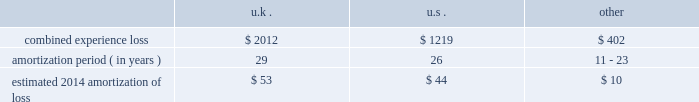Period .
The discount reflects our incremental borrowing rate , which matches the lifetime of the liability .
Significant changes in the discount rate selected or the estimations of sublease income in the case of leases could impact the amounts recorded .
Other associated costs with restructuring activities we recognize other costs associated with restructuring activities as they are incurred , including moving costs and consulting and legal fees .
Pensions we sponsor defined benefit pension plans throughout the world .
Our most significant plans are located in the u.s. , the u.k. , the netherlands and canada .
Our significant u.s. , u.k .
And canadian pension plans are closed to new entrants .
We have ceased crediting future benefits relating to salary and service for our u.s. , u.k .
And canadian plans .
Recognition of gains and losses and prior service certain changes in the value of the obligation and in the value of plan assets , which may occur due to various factors such as changes in the discount rate and actuarial assumptions , actual demographic experience and/or plan asset performance are not immediately recognized in net income .
Such changes are recognized in other comprehensive income and are amortized into net income as part of the net periodic benefit cost .
Unrecognized gains and losses that have been deferred in other comprehensive income , as previously described , are amortized into compensation and benefits expense as a component of periodic pension expense based on the average expected future service of active employees for our plans in the netherlands and canada , or the average life expectancy of the u.s .
And u.k .
Plan members .
After the effective date of the plan amendments to cease crediting future benefits relating to service , unrecognized gains and losses are also be based on the average life expectancy of members in the canadian plans .
We amortize any prior service expense or credits that arise as a result of plan changes over a period consistent with the amortization of gains and losses .
As of december 31 , 2013 , our pension plans have deferred losses that have not yet been recognized through income in the consolidated financial statements .
We amortize unrecognized actuarial losses outside of a corridor , which is defined as 10% ( 10 % ) of the greater of market-related value of plan assets or projected benefit obligation .
To the extent not offset by future gains , incremental amortization as calculated above will continue to affect future pension expense similarly until fully amortized .
The table discloses our combined experience loss , the number of years over which we are amortizing the experience loss , and the estimated 2014 amortization of loss by country ( amounts in millions ) : .
The unrecognized prior service cost at december 31 , 2013 was $ 27 million in the u.k .
And other plans .
For the u.s .
Pension plans we use a market-related valuation of assets approach to determine the expected return on assets , which is a component of net periodic benefit cost recognized in the consolidated statements of income .
This approach recognizes 20% ( 20 % ) of any gains or losses in the current year's value of market-related assets , with the remaining 80% ( 80 % ) spread over the next four years .
As this approach recognizes gains or losses over a five-year period , the future value of assets and therefore , our net periodic benefit cost will be impacted as previously deferred gains or losses are recorded .
As of december 31 , 2013 , the market-related value of assets was $ 1.8 billion .
We do not use the market-related valuation approach to determine the funded status of the u.s .
Plans recorded in the consolidated statements of financial position .
Instead , we record and present the funded status in the consolidated statements of financial position based on the fair value of the plan assets .
As of december 31 , 2013 , the fair value of plan assets was $ 1.9 billion .
Our non-u.s .
Plans use fair value to determine expected return on assets. .
What is the total estimated amortization of loss in 2014 for aon , ( in millions ) ? 
Computations: ((53 + 44) + 10)
Answer: 107.0. Period .
The discount reflects our incremental borrowing rate , which matches the lifetime of the liability .
Significant changes in the discount rate selected or the estimations of sublease income in the case of leases could impact the amounts recorded .
Other associated costs with restructuring activities we recognize other costs associated with restructuring activities as they are incurred , including moving costs and consulting and legal fees .
Pensions we sponsor defined benefit pension plans throughout the world .
Our most significant plans are located in the u.s. , the u.k. , the netherlands and canada .
Our significant u.s. , u.k .
And canadian pension plans are closed to new entrants .
We have ceased crediting future benefits relating to salary and service for our u.s. , u.k .
And canadian plans .
Recognition of gains and losses and prior service certain changes in the value of the obligation and in the value of plan assets , which may occur due to various factors such as changes in the discount rate and actuarial assumptions , actual demographic experience and/or plan asset performance are not immediately recognized in net income .
Such changes are recognized in other comprehensive income and are amortized into net income as part of the net periodic benefit cost .
Unrecognized gains and losses that have been deferred in other comprehensive income , as previously described , are amortized into compensation and benefits expense as a component of periodic pension expense based on the average expected future service of active employees for our plans in the netherlands and canada , or the average life expectancy of the u.s .
And u.k .
Plan members .
After the effective date of the plan amendments to cease crediting future benefits relating to service , unrecognized gains and losses are also be based on the average life expectancy of members in the canadian plans .
We amortize any prior service expense or credits that arise as a result of plan changes over a period consistent with the amortization of gains and losses .
As of december 31 , 2013 , our pension plans have deferred losses that have not yet been recognized through income in the consolidated financial statements .
We amortize unrecognized actuarial losses outside of a corridor , which is defined as 10% ( 10 % ) of the greater of market-related value of plan assets or projected benefit obligation .
To the extent not offset by future gains , incremental amortization as calculated above will continue to affect future pension expense similarly until fully amortized .
The table discloses our combined experience loss , the number of years over which we are amortizing the experience loss , and the estimated 2014 amortization of loss by country ( amounts in millions ) : .
The unrecognized prior service cost at december 31 , 2013 was $ 27 million in the u.k .
And other plans .
For the u.s .
Pension plans we use a market-related valuation of assets approach to determine the expected return on assets , which is a component of net periodic benefit cost recognized in the consolidated statements of income .
This approach recognizes 20% ( 20 % ) of any gains or losses in the current year's value of market-related assets , with the remaining 80% ( 80 % ) spread over the next four years .
As this approach recognizes gains or losses over a five-year period , the future value of assets and therefore , our net periodic benefit cost will be impacted as previously deferred gains or losses are recorded .
As of december 31 , 2013 , the market-related value of assets was $ 1.8 billion .
We do not use the market-related valuation approach to determine the funded status of the u.s .
Plans recorded in the consolidated statements of financial position .
Instead , we record and present the funded status in the consolidated statements of financial position based on the fair value of the plan assets .
As of december 31 , 2013 , the fair value of plan assets was $ 1.9 billion .
Our non-u.s .
Plans use fair value to determine expected return on assets. .
In 2014 what was the combined total experience loss? 
Computations: ((2012 + 1219) + 402)
Answer: 3633.0. 